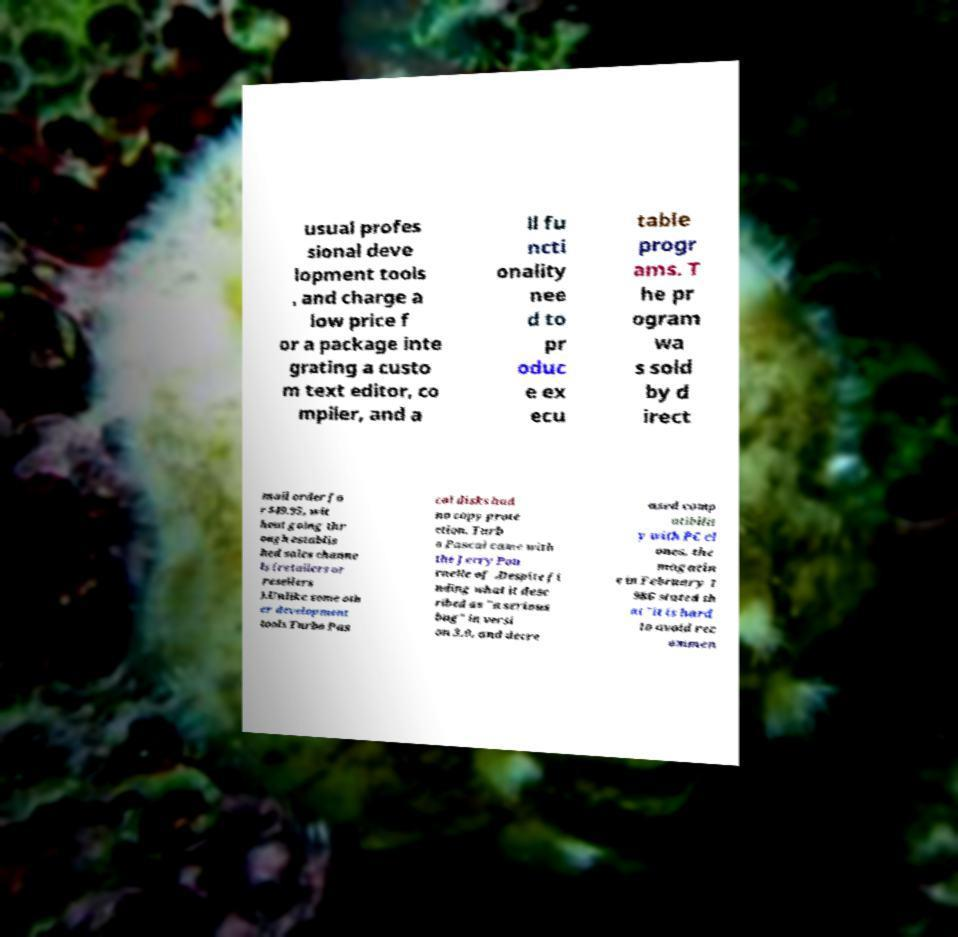Could you extract and type out the text from this image? usual profes sional deve lopment tools , and charge a low price f or a package inte grating a custo m text editor, co mpiler, and a ll fu ncti onality nee d to pr oduc e ex ecu table progr ams. T he pr ogram wa s sold by d irect mail order fo r $49.95, wit hout going thr ough establis hed sales channe ls (retailers or resellers ).Unlike some oth er development tools Turbo Pas cal disks had no copy prote ction. Turb o Pascal came with the Jerry Pou rnelle of .Despite fi nding what it desc ribed as "a serious bug" in versi on 3.0, and decre ased comp atibilit y with PC cl ones, the magazin e in February 1 986 stated th at "it is hard to avoid rec ommen 